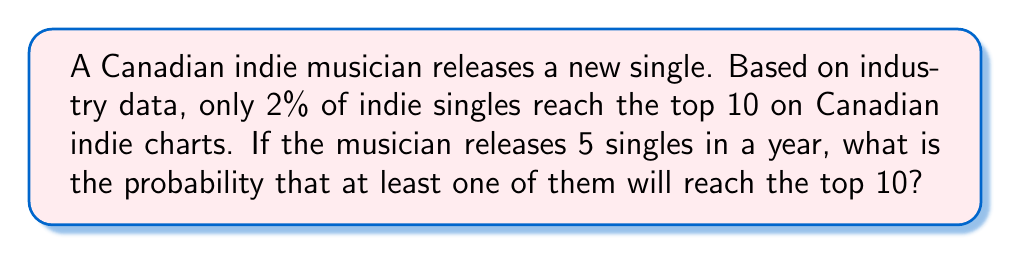Provide a solution to this math problem. Let's approach this step-by-step:

1) First, let's define our probability:
   $p$ = probability of a single reaching the top 10 = 0.02
   $q$ = probability of a single not reaching the top 10 = 1 - p = 0.98

2) We want to find the probability of at least one success in 5 trials. It's easier to calculate the probability of no successes and then subtract from 1.

3) The probability of no successes in 5 trials is:
   $q^5 = 0.98^5 = 0.9039$

4) Therefore, the probability of at least one success is:
   $1 - q^5 = 1 - 0.9039 = 0.0961$

5) We can verify this using the binomial probability formula:
   $$P(X \geq 1) = 1 - P(X = 0) = 1 - \binom{5}{0}p^0q^5 = 1 - 0.9039 = 0.0961$$

Thus, there is approximately a 9.61% chance that at least one of the 5 singles will reach the top 10 on Canadian indie charts.
Answer: 0.0961 or 9.61% 